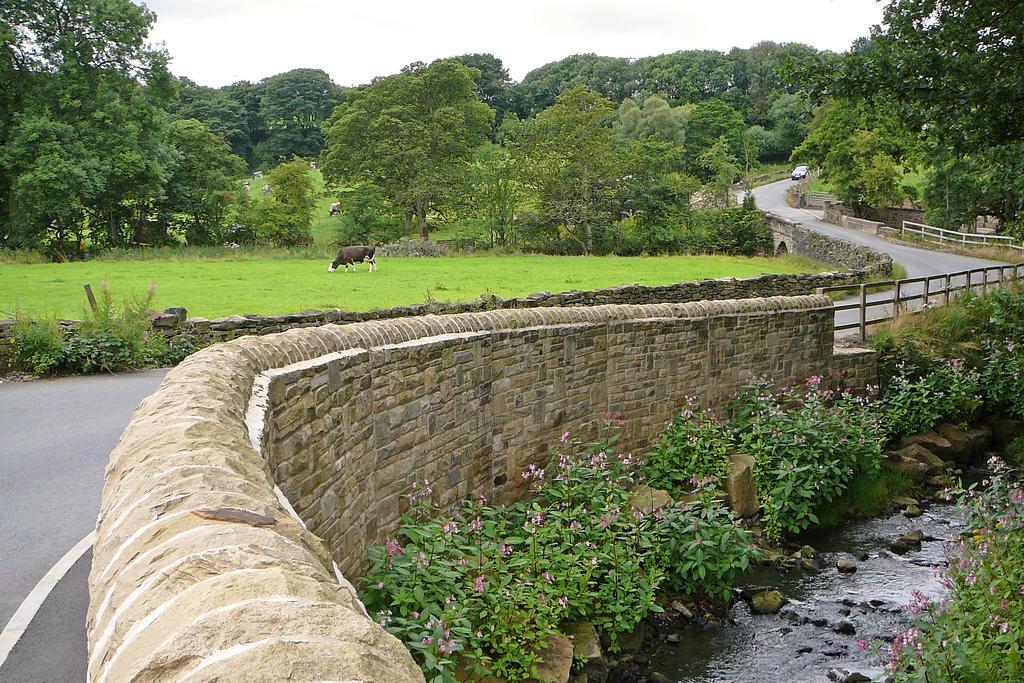Describe this image in one or two sentences. There is a river with stones. On the sides there are plants and stones. Also there is a wall with railings. There is a road with a vehicle. Also there is grass, animals and trees. In the background there is sky. 